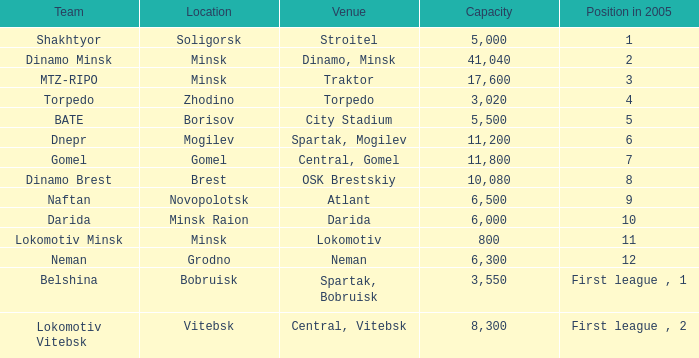Can you tell me the Capacity that has the Position in 2005 of 8? 10080.0. 